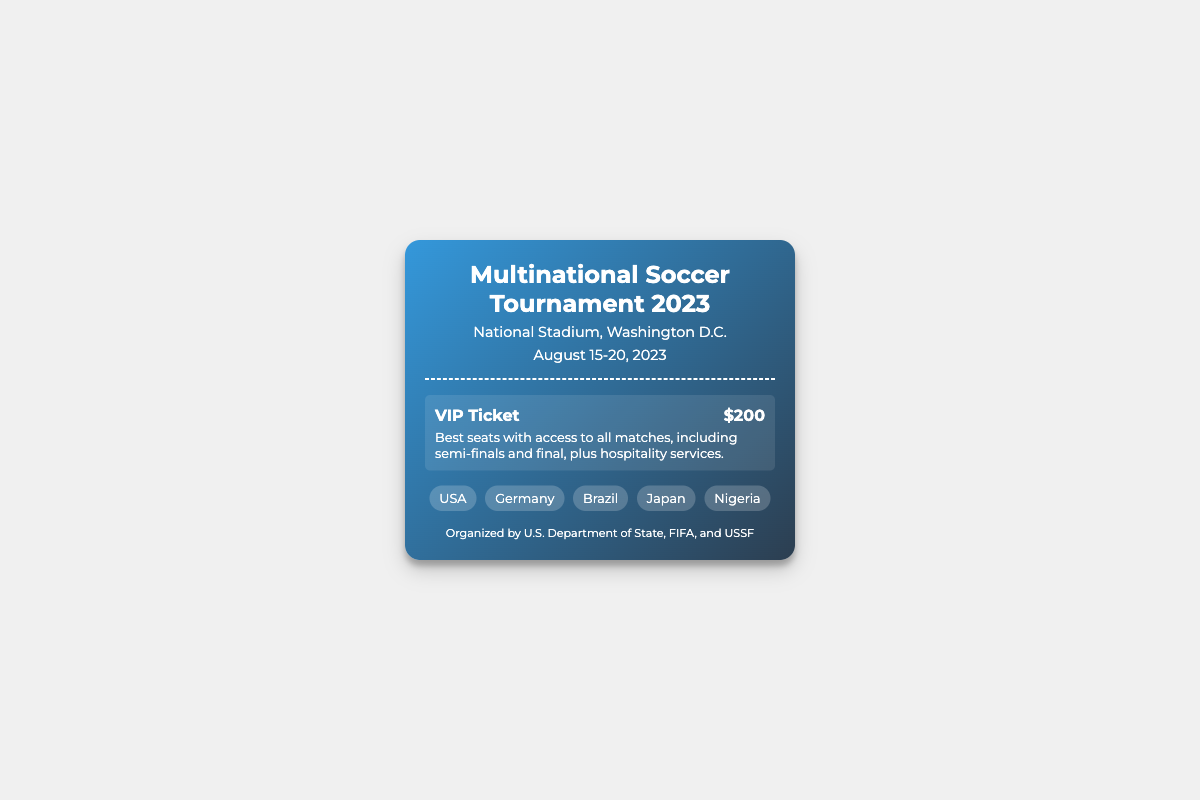what is the title of the event? The title of the event is prominently displayed at the top of the ticket document.
Answer: Multinational Soccer Tournament 2023 where is the event held? The venue information is provided under the title.
Answer: National Stadium, Washington D.C when does the event take place? The date of the event is listed below the venue information.
Answer: August 15-20, 2023 what is the price of a VIP Ticket? The ticket price is mentioned alongside the type of ticket, highlighting key information.
Answer: $200 what features come with a VIP Ticket? The description under the VIP Ticket outlines the benefits and features associated with that ticket type.
Answer: Best seats with access to all matches, including semi-finals and final, plus hospitality services which countries are mentioned in the document? The document lists countries as part of the ticket information in the designated countries section.
Answer: USA, Germany, Brazil, Japan, Nigeria who is organizing the event? The footer section specifies the organizing bodies responsible for the event.
Answer: U.S. Department of State, FIFA, and USSF how many days does the event last? The date range shows the total duration of the event by counting the number of days between the start and end dates.
Answer: 6 days what kind of seating does a VIP Ticket provide? The benefits outlined in the description section indicate the seating arrangements for VIP attendees.
Answer: Best seats 